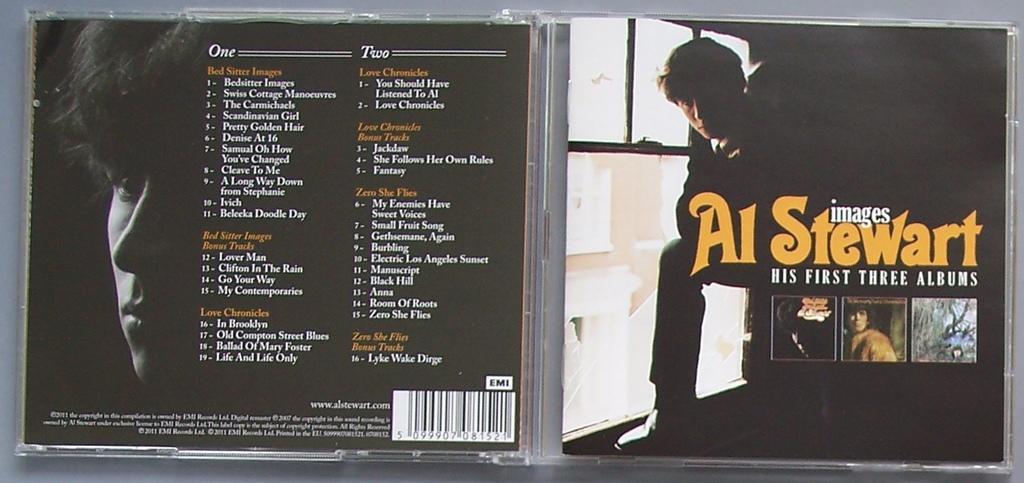Can you describe this image briefly? In this image I can see four persons, text, logo, trees, vehicle, building and window. This image looks like an edited photo. 